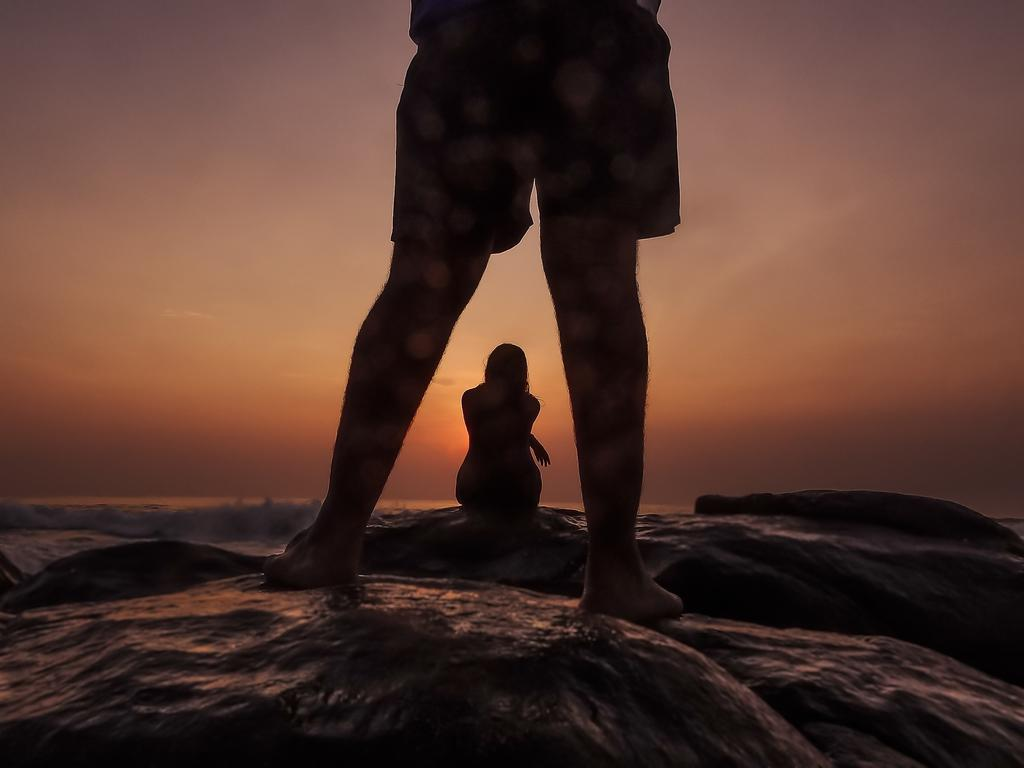What is visible on the rocks in the image? There are legs of a person on the rocks. Can you describe the girl in the image? There is a girl sitting on a rock in the background. What is the natural element visible in the background? Water is visible in the background. What is the condition of the sky in the image? Clouds are present in the sky. What type of cheese is being used to create the river in the image? There is no cheese or river present in the image. How far away is the girl from the person on the rocks? The distance between the girl and the person on the rocks cannot be determined from the image. 